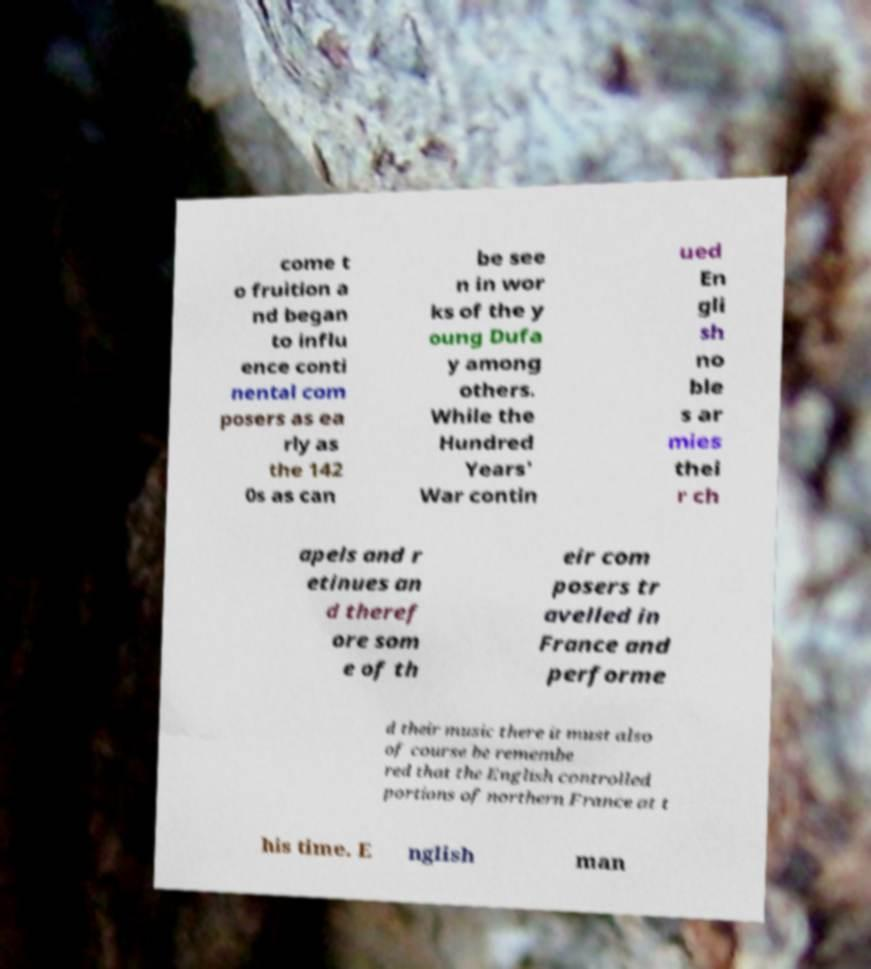For documentation purposes, I need the text within this image transcribed. Could you provide that? come t o fruition a nd began to influ ence conti nental com posers as ea rly as the 142 0s as can be see n in wor ks of the y oung Dufa y among others. While the Hundred Years' War contin ued En gli sh no ble s ar mies thei r ch apels and r etinues an d theref ore som e of th eir com posers tr avelled in France and performe d their music there it must also of course be remembe red that the English controlled portions of northern France at t his time. E nglish man 